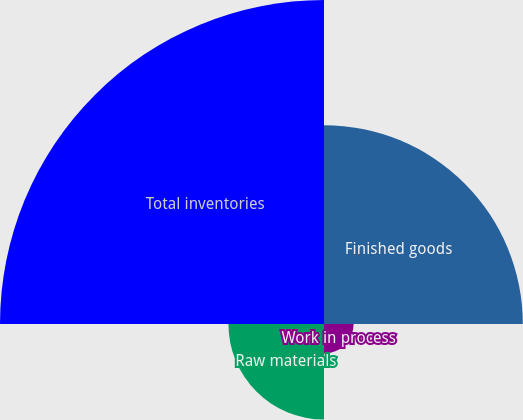Convert chart. <chart><loc_0><loc_0><loc_500><loc_500><pie_chart><fcel>Finished goods<fcel>Work in process<fcel>Raw materials<fcel>Total inventories<nl><fcel>30.68%<fcel>4.57%<fcel>14.75%<fcel>50.0%<nl></chart> 